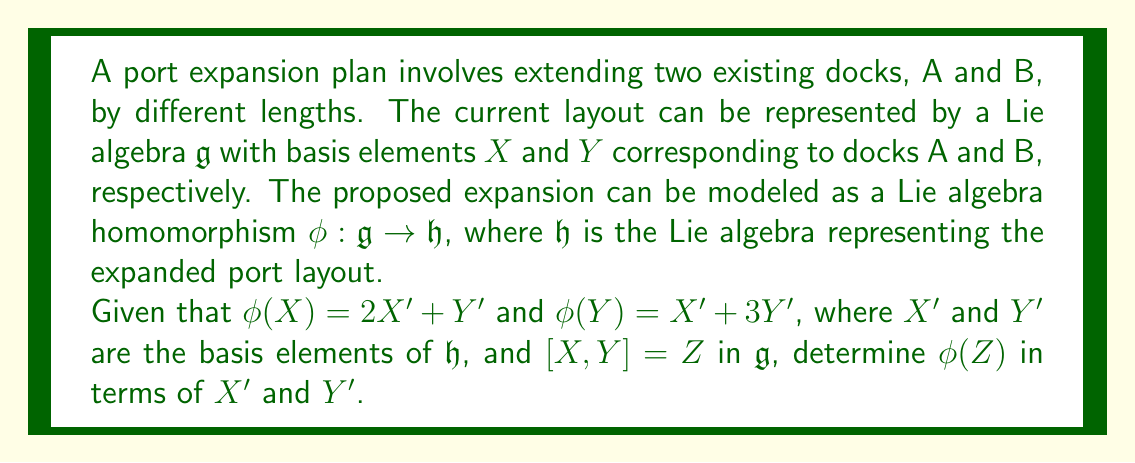Solve this math problem. To solve this problem, we'll follow these steps:

1) Recall that a Lie algebra homomorphism $\phi$ must preserve the Lie bracket operation. This means:

   $\phi([X, Y]) = [\phi(X), \phi(Y)]$

2) We're given that $[X, Y] = Z$ in $\mathfrak{g}$, so:

   $\phi(Z) = \phi([X, Y]) = [\phi(X), \phi(Y)]$

3) Now, let's calculate $[\phi(X), \phi(Y)]$:

   $[\phi(X), \phi(Y)] = [(2X' + Y'), (X' + 3Y')]$

4) To evaluate this bracket, we'll use the bilinearity and antisymmetry properties of the Lie bracket:

   $[(2X' + Y'), (X' + 3Y')] = 2[X', X'] + 2[X', 3Y'] + [Y', X'] + [Y', 3Y']$
                               $= 0 + 6[X', Y'] - [X', Y'] + 0$
                               $= 5[X', Y']$

5) Therefore:

   $\phi(Z) = 5[X', Y']$

This result shows how the expansion plan affects the structural relationships between the docks in the new layout.
Answer: $\phi(Z) = 5[X', Y']$ 